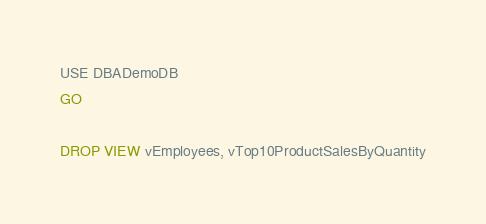Convert code to text. <code><loc_0><loc_0><loc_500><loc_500><_SQL_>USE DBADemoDB
GO

DROP VIEW vEmployees, vTop10ProductSalesByQuantity</code> 